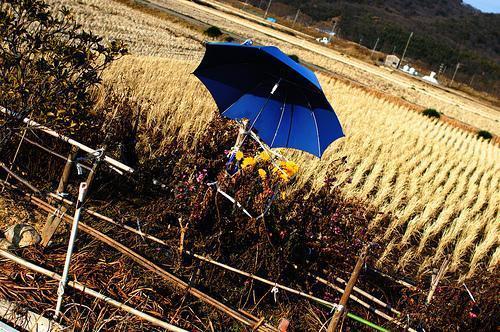How many umbrellas are there?
Give a very brief answer. 1. How many umbrellas are pictured?
Give a very brief answer. 1. 